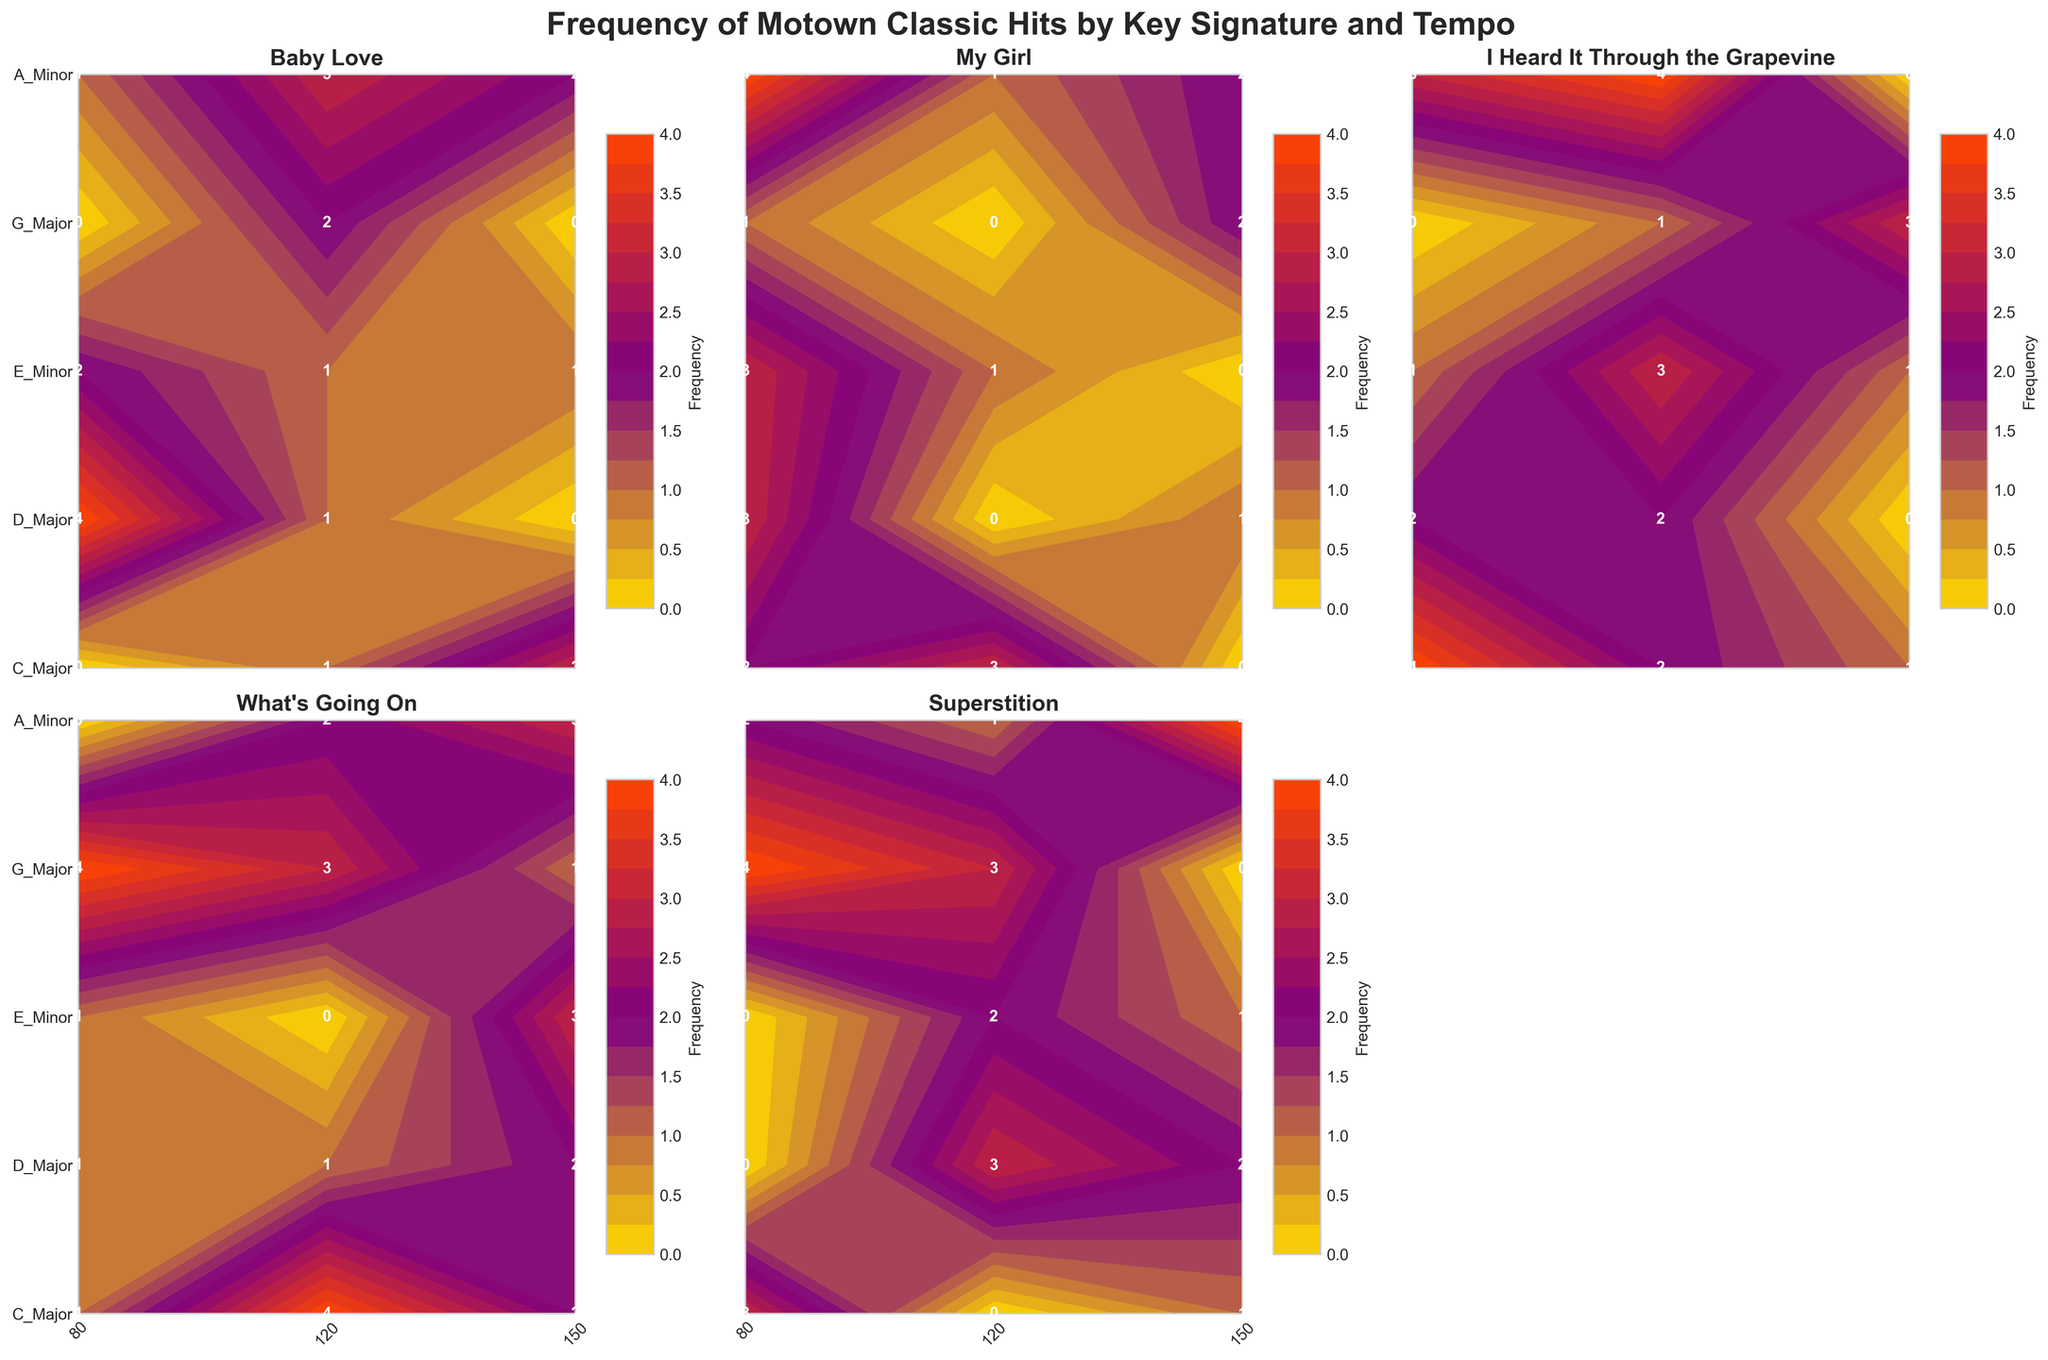What's the title of the figure? The title of the figure is a textual element placed at the top of the plot. It is meant to provide an overall description of what the figure represents. It is written in a bold font, making it easy to spot.
Answer: Frequency of Motown Classic Hits by Key Signature and Tempo What is the key signature with the highest frequency of "Superstition" at a tempo of 80 BPM? To answer this, locate the contour plot for "Superstition". Find the column corresponding to a tempo of 80 BPM. The key signature with the highest labeled frequency value will answer this question.
Answer: E_Minor Which key signature shows the most songs overall at 120 BPM across all tracks? For this, sum the frequencies across all songs at 120 BPM for each key signature. Compare these sums to determine which key signature has the highest cumulative frequency at this tempo.
Answer: G_Major How many key signatures are compared in the figure? The number of unique key signatures can be identified by counting distinct labels along the y-axis of the contour plots.
Answer: 5 Which song has the most even distribution of frequencies across different tempos in C Major? Examine the contour plots for each song and focus on the one that represents data for C Major. Look for the song where the frequency values don't vary drastically with changes in tempo.
Answer: Baby_Love What tempo shows the highest frequency for "My Girl" in G Major? Look at the contour plot for "My Girl", then find the row corresponding to G Major. Identify the tempo with the highest labeled frequency value on that row.
Answer: 80 BPM What is the average frequency of "I Heard It Through the Grapevine" in A Minor across all tempos? Determine individual frequencies of the song in A Minor across all tempos, then calculate their average. The values are 4, 2, and 1. Adding gives 4 + 2 + 1 = 7, and average is 7 / 3.
Answer: 2.33 Does "What's Going On" appear more frequently in D Major or E Minor? For "What's Going On", compare the summed frequencies in the rows corresponding to D Major and E Minor. Add values for D Major (1 + 0 + 3 = 4) and E Minor (4 + 3 + 1 = 8). E Minor has higher total.
Answer: E_Minor Which song has the highest frequency in any key signature-tempo pair and what is that frequency? Scan all contour plots to find the highest labeled frequency and note the song where it occurs.
Answer: My_Girl (Frequency 4) 